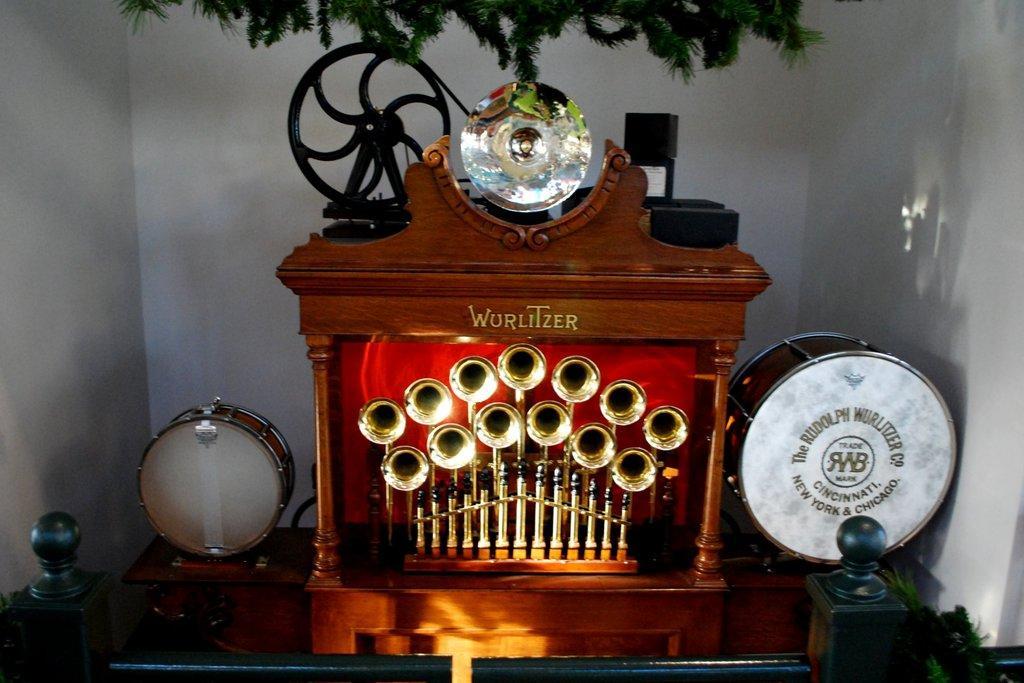Could you give a brief overview of what you see in this image? In this image we can see few musical instruments. There are few leaves at the top of the image. There is some text on an object. There is a barrier in the image. There is a wall in the image. 